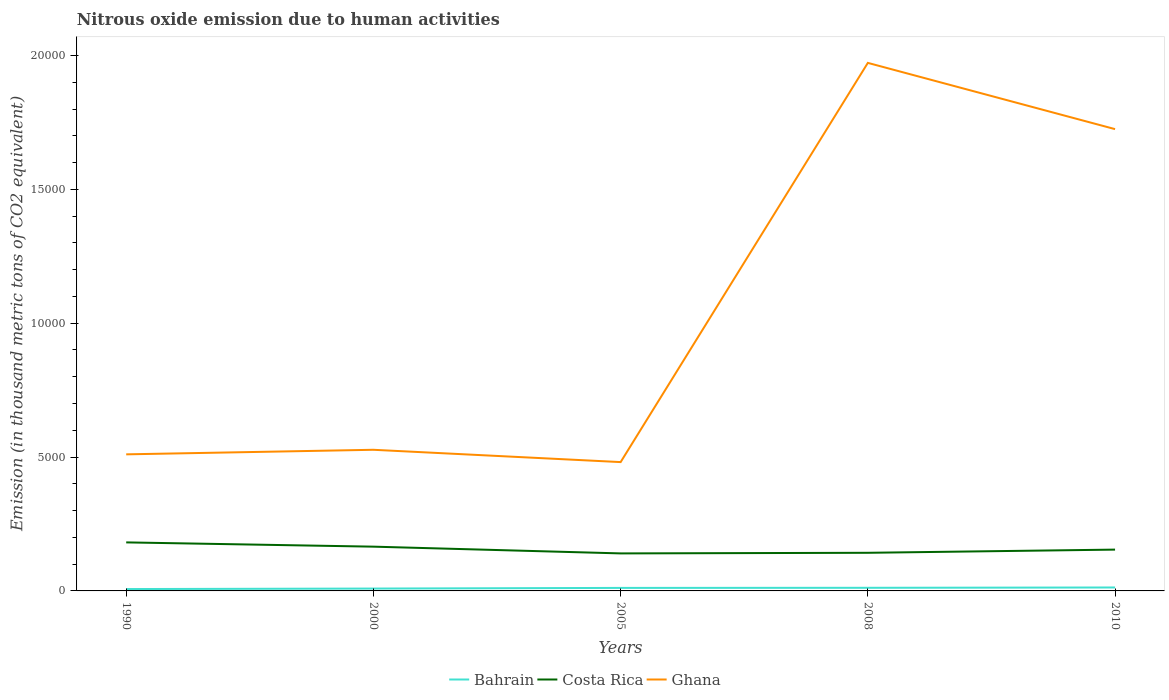How many different coloured lines are there?
Provide a succinct answer. 3. Across all years, what is the maximum amount of nitrous oxide emitted in Bahrain?
Your answer should be compact. 70.2. What is the total amount of nitrous oxide emitted in Costa Rica in the graph?
Provide a short and direct response. 411.5. What is the difference between the highest and the second highest amount of nitrous oxide emitted in Costa Rica?
Your response must be concise. 411.5. Is the amount of nitrous oxide emitted in Bahrain strictly greater than the amount of nitrous oxide emitted in Costa Rica over the years?
Your response must be concise. Yes. What is the difference between two consecutive major ticks on the Y-axis?
Your answer should be compact. 5000. Does the graph contain any zero values?
Provide a short and direct response. No. Does the graph contain grids?
Provide a succinct answer. No. How many legend labels are there?
Make the answer very short. 3. How are the legend labels stacked?
Your answer should be very brief. Horizontal. What is the title of the graph?
Your answer should be compact. Nitrous oxide emission due to human activities. Does "Bahrain" appear as one of the legend labels in the graph?
Your answer should be very brief. Yes. What is the label or title of the X-axis?
Your response must be concise. Years. What is the label or title of the Y-axis?
Keep it short and to the point. Emission (in thousand metric tons of CO2 equivalent). What is the Emission (in thousand metric tons of CO2 equivalent) of Bahrain in 1990?
Provide a succinct answer. 70.2. What is the Emission (in thousand metric tons of CO2 equivalent) of Costa Rica in 1990?
Keep it short and to the point. 1812.5. What is the Emission (in thousand metric tons of CO2 equivalent) of Ghana in 1990?
Keep it short and to the point. 5101.4. What is the Emission (in thousand metric tons of CO2 equivalent) of Bahrain in 2000?
Offer a terse response. 88.2. What is the Emission (in thousand metric tons of CO2 equivalent) of Costa Rica in 2000?
Your answer should be compact. 1653.2. What is the Emission (in thousand metric tons of CO2 equivalent) of Ghana in 2000?
Your answer should be compact. 5271.4. What is the Emission (in thousand metric tons of CO2 equivalent) in Bahrain in 2005?
Make the answer very short. 112.9. What is the Emission (in thousand metric tons of CO2 equivalent) in Costa Rica in 2005?
Offer a terse response. 1401. What is the Emission (in thousand metric tons of CO2 equivalent) in Ghana in 2005?
Provide a succinct answer. 4812. What is the Emission (in thousand metric tons of CO2 equivalent) in Bahrain in 2008?
Ensure brevity in your answer.  116.7. What is the Emission (in thousand metric tons of CO2 equivalent) in Costa Rica in 2008?
Make the answer very short. 1424.1. What is the Emission (in thousand metric tons of CO2 equivalent) in Ghana in 2008?
Provide a succinct answer. 1.97e+04. What is the Emission (in thousand metric tons of CO2 equivalent) in Bahrain in 2010?
Give a very brief answer. 128.6. What is the Emission (in thousand metric tons of CO2 equivalent) of Costa Rica in 2010?
Make the answer very short. 1543. What is the Emission (in thousand metric tons of CO2 equivalent) of Ghana in 2010?
Provide a succinct answer. 1.72e+04. Across all years, what is the maximum Emission (in thousand metric tons of CO2 equivalent) of Bahrain?
Your answer should be compact. 128.6. Across all years, what is the maximum Emission (in thousand metric tons of CO2 equivalent) in Costa Rica?
Your answer should be compact. 1812.5. Across all years, what is the maximum Emission (in thousand metric tons of CO2 equivalent) of Ghana?
Keep it short and to the point. 1.97e+04. Across all years, what is the minimum Emission (in thousand metric tons of CO2 equivalent) of Bahrain?
Make the answer very short. 70.2. Across all years, what is the minimum Emission (in thousand metric tons of CO2 equivalent) in Costa Rica?
Provide a succinct answer. 1401. Across all years, what is the minimum Emission (in thousand metric tons of CO2 equivalent) of Ghana?
Keep it short and to the point. 4812. What is the total Emission (in thousand metric tons of CO2 equivalent) of Bahrain in the graph?
Offer a terse response. 516.6. What is the total Emission (in thousand metric tons of CO2 equivalent) in Costa Rica in the graph?
Ensure brevity in your answer.  7833.8. What is the total Emission (in thousand metric tons of CO2 equivalent) in Ghana in the graph?
Your answer should be compact. 5.22e+04. What is the difference between the Emission (in thousand metric tons of CO2 equivalent) of Bahrain in 1990 and that in 2000?
Your response must be concise. -18. What is the difference between the Emission (in thousand metric tons of CO2 equivalent) of Costa Rica in 1990 and that in 2000?
Your answer should be compact. 159.3. What is the difference between the Emission (in thousand metric tons of CO2 equivalent) in Ghana in 1990 and that in 2000?
Your answer should be very brief. -170. What is the difference between the Emission (in thousand metric tons of CO2 equivalent) in Bahrain in 1990 and that in 2005?
Give a very brief answer. -42.7. What is the difference between the Emission (in thousand metric tons of CO2 equivalent) of Costa Rica in 1990 and that in 2005?
Offer a terse response. 411.5. What is the difference between the Emission (in thousand metric tons of CO2 equivalent) in Ghana in 1990 and that in 2005?
Ensure brevity in your answer.  289.4. What is the difference between the Emission (in thousand metric tons of CO2 equivalent) of Bahrain in 1990 and that in 2008?
Provide a short and direct response. -46.5. What is the difference between the Emission (in thousand metric tons of CO2 equivalent) in Costa Rica in 1990 and that in 2008?
Give a very brief answer. 388.4. What is the difference between the Emission (in thousand metric tons of CO2 equivalent) of Ghana in 1990 and that in 2008?
Your answer should be compact. -1.46e+04. What is the difference between the Emission (in thousand metric tons of CO2 equivalent) of Bahrain in 1990 and that in 2010?
Provide a short and direct response. -58.4. What is the difference between the Emission (in thousand metric tons of CO2 equivalent) of Costa Rica in 1990 and that in 2010?
Give a very brief answer. 269.5. What is the difference between the Emission (in thousand metric tons of CO2 equivalent) in Ghana in 1990 and that in 2010?
Make the answer very short. -1.21e+04. What is the difference between the Emission (in thousand metric tons of CO2 equivalent) in Bahrain in 2000 and that in 2005?
Your answer should be compact. -24.7. What is the difference between the Emission (in thousand metric tons of CO2 equivalent) in Costa Rica in 2000 and that in 2005?
Keep it short and to the point. 252.2. What is the difference between the Emission (in thousand metric tons of CO2 equivalent) of Ghana in 2000 and that in 2005?
Offer a terse response. 459.4. What is the difference between the Emission (in thousand metric tons of CO2 equivalent) of Bahrain in 2000 and that in 2008?
Make the answer very short. -28.5. What is the difference between the Emission (in thousand metric tons of CO2 equivalent) in Costa Rica in 2000 and that in 2008?
Offer a very short reply. 229.1. What is the difference between the Emission (in thousand metric tons of CO2 equivalent) in Ghana in 2000 and that in 2008?
Provide a short and direct response. -1.45e+04. What is the difference between the Emission (in thousand metric tons of CO2 equivalent) of Bahrain in 2000 and that in 2010?
Give a very brief answer. -40.4. What is the difference between the Emission (in thousand metric tons of CO2 equivalent) in Costa Rica in 2000 and that in 2010?
Your answer should be very brief. 110.2. What is the difference between the Emission (in thousand metric tons of CO2 equivalent) of Ghana in 2000 and that in 2010?
Provide a succinct answer. -1.20e+04. What is the difference between the Emission (in thousand metric tons of CO2 equivalent) of Bahrain in 2005 and that in 2008?
Provide a succinct answer. -3.8. What is the difference between the Emission (in thousand metric tons of CO2 equivalent) of Costa Rica in 2005 and that in 2008?
Offer a terse response. -23.1. What is the difference between the Emission (in thousand metric tons of CO2 equivalent) in Ghana in 2005 and that in 2008?
Provide a short and direct response. -1.49e+04. What is the difference between the Emission (in thousand metric tons of CO2 equivalent) of Bahrain in 2005 and that in 2010?
Your response must be concise. -15.7. What is the difference between the Emission (in thousand metric tons of CO2 equivalent) of Costa Rica in 2005 and that in 2010?
Provide a short and direct response. -142. What is the difference between the Emission (in thousand metric tons of CO2 equivalent) in Ghana in 2005 and that in 2010?
Your response must be concise. -1.24e+04. What is the difference between the Emission (in thousand metric tons of CO2 equivalent) in Costa Rica in 2008 and that in 2010?
Your answer should be compact. -118.9. What is the difference between the Emission (in thousand metric tons of CO2 equivalent) of Ghana in 2008 and that in 2010?
Provide a succinct answer. 2474. What is the difference between the Emission (in thousand metric tons of CO2 equivalent) of Bahrain in 1990 and the Emission (in thousand metric tons of CO2 equivalent) of Costa Rica in 2000?
Ensure brevity in your answer.  -1583. What is the difference between the Emission (in thousand metric tons of CO2 equivalent) of Bahrain in 1990 and the Emission (in thousand metric tons of CO2 equivalent) of Ghana in 2000?
Give a very brief answer. -5201.2. What is the difference between the Emission (in thousand metric tons of CO2 equivalent) in Costa Rica in 1990 and the Emission (in thousand metric tons of CO2 equivalent) in Ghana in 2000?
Give a very brief answer. -3458.9. What is the difference between the Emission (in thousand metric tons of CO2 equivalent) of Bahrain in 1990 and the Emission (in thousand metric tons of CO2 equivalent) of Costa Rica in 2005?
Your answer should be compact. -1330.8. What is the difference between the Emission (in thousand metric tons of CO2 equivalent) in Bahrain in 1990 and the Emission (in thousand metric tons of CO2 equivalent) in Ghana in 2005?
Ensure brevity in your answer.  -4741.8. What is the difference between the Emission (in thousand metric tons of CO2 equivalent) of Costa Rica in 1990 and the Emission (in thousand metric tons of CO2 equivalent) of Ghana in 2005?
Offer a very short reply. -2999.5. What is the difference between the Emission (in thousand metric tons of CO2 equivalent) in Bahrain in 1990 and the Emission (in thousand metric tons of CO2 equivalent) in Costa Rica in 2008?
Your response must be concise. -1353.9. What is the difference between the Emission (in thousand metric tons of CO2 equivalent) in Bahrain in 1990 and the Emission (in thousand metric tons of CO2 equivalent) in Ghana in 2008?
Provide a short and direct response. -1.97e+04. What is the difference between the Emission (in thousand metric tons of CO2 equivalent) of Costa Rica in 1990 and the Emission (in thousand metric tons of CO2 equivalent) of Ghana in 2008?
Your answer should be very brief. -1.79e+04. What is the difference between the Emission (in thousand metric tons of CO2 equivalent) of Bahrain in 1990 and the Emission (in thousand metric tons of CO2 equivalent) of Costa Rica in 2010?
Give a very brief answer. -1472.8. What is the difference between the Emission (in thousand metric tons of CO2 equivalent) in Bahrain in 1990 and the Emission (in thousand metric tons of CO2 equivalent) in Ghana in 2010?
Offer a terse response. -1.72e+04. What is the difference between the Emission (in thousand metric tons of CO2 equivalent) of Costa Rica in 1990 and the Emission (in thousand metric tons of CO2 equivalent) of Ghana in 2010?
Offer a very short reply. -1.54e+04. What is the difference between the Emission (in thousand metric tons of CO2 equivalent) in Bahrain in 2000 and the Emission (in thousand metric tons of CO2 equivalent) in Costa Rica in 2005?
Give a very brief answer. -1312.8. What is the difference between the Emission (in thousand metric tons of CO2 equivalent) of Bahrain in 2000 and the Emission (in thousand metric tons of CO2 equivalent) of Ghana in 2005?
Offer a very short reply. -4723.8. What is the difference between the Emission (in thousand metric tons of CO2 equivalent) of Costa Rica in 2000 and the Emission (in thousand metric tons of CO2 equivalent) of Ghana in 2005?
Provide a succinct answer. -3158.8. What is the difference between the Emission (in thousand metric tons of CO2 equivalent) of Bahrain in 2000 and the Emission (in thousand metric tons of CO2 equivalent) of Costa Rica in 2008?
Ensure brevity in your answer.  -1335.9. What is the difference between the Emission (in thousand metric tons of CO2 equivalent) in Bahrain in 2000 and the Emission (in thousand metric tons of CO2 equivalent) in Ghana in 2008?
Give a very brief answer. -1.96e+04. What is the difference between the Emission (in thousand metric tons of CO2 equivalent) in Costa Rica in 2000 and the Emission (in thousand metric tons of CO2 equivalent) in Ghana in 2008?
Offer a terse response. -1.81e+04. What is the difference between the Emission (in thousand metric tons of CO2 equivalent) in Bahrain in 2000 and the Emission (in thousand metric tons of CO2 equivalent) in Costa Rica in 2010?
Ensure brevity in your answer.  -1454.8. What is the difference between the Emission (in thousand metric tons of CO2 equivalent) of Bahrain in 2000 and the Emission (in thousand metric tons of CO2 equivalent) of Ghana in 2010?
Your response must be concise. -1.72e+04. What is the difference between the Emission (in thousand metric tons of CO2 equivalent) in Costa Rica in 2000 and the Emission (in thousand metric tons of CO2 equivalent) in Ghana in 2010?
Make the answer very short. -1.56e+04. What is the difference between the Emission (in thousand metric tons of CO2 equivalent) in Bahrain in 2005 and the Emission (in thousand metric tons of CO2 equivalent) in Costa Rica in 2008?
Your response must be concise. -1311.2. What is the difference between the Emission (in thousand metric tons of CO2 equivalent) of Bahrain in 2005 and the Emission (in thousand metric tons of CO2 equivalent) of Ghana in 2008?
Provide a succinct answer. -1.96e+04. What is the difference between the Emission (in thousand metric tons of CO2 equivalent) in Costa Rica in 2005 and the Emission (in thousand metric tons of CO2 equivalent) in Ghana in 2008?
Provide a succinct answer. -1.83e+04. What is the difference between the Emission (in thousand metric tons of CO2 equivalent) of Bahrain in 2005 and the Emission (in thousand metric tons of CO2 equivalent) of Costa Rica in 2010?
Provide a short and direct response. -1430.1. What is the difference between the Emission (in thousand metric tons of CO2 equivalent) of Bahrain in 2005 and the Emission (in thousand metric tons of CO2 equivalent) of Ghana in 2010?
Offer a very short reply. -1.71e+04. What is the difference between the Emission (in thousand metric tons of CO2 equivalent) in Costa Rica in 2005 and the Emission (in thousand metric tons of CO2 equivalent) in Ghana in 2010?
Your answer should be compact. -1.58e+04. What is the difference between the Emission (in thousand metric tons of CO2 equivalent) of Bahrain in 2008 and the Emission (in thousand metric tons of CO2 equivalent) of Costa Rica in 2010?
Give a very brief answer. -1426.3. What is the difference between the Emission (in thousand metric tons of CO2 equivalent) of Bahrain in 2008 and the Emission (in thousand metric tons of CO2 equivalent) of Ghana in 2010?
Your answer should be very brief. -1.71e+04. What is the difference between the Emission (in thousand metric tons of CO2 equivalent) in Costa Rica in 2008 and the Emission (in thousand metric tons of CO2 equivalent) in Ghana in 2010?
Your answer should be compact. -1.58e+04. What is the average Emission (in thousand metric tons of CO2 equivalent) in Bahrain per year?
Your answer should be very brief. 103.32. What is the average Emission (in thousand metric tons of CO2 equivalent) of Costa Rica per year?
Make the answer very short. 1566.76. What is the average Emission (in thousand metric tons of CO2 equivalent) of Ghana per year?
Offer a very short reply. 1.04e+04. In the year 1990, what is the difference between the Emission (in thousand metric tons of CO2 equivalent) of Bahrain and Emission (in thousand metric tons of CO2 equivalent) of Costa Rica?
Your answer should be compact. -1742.3. In the year 1990, what is the difference between the Emission (in thousand metric tons of CO2 equivalent) in Bahrain and Emission (in thousand metric tons of CO2 equivalent) in Ghana?
Provide a short and direct response. -5031.2. In the year 1990, what is the difference between the Emission (in thousand metric tons of CO2 equivalent) of Costa Rica and Emission (in thousand metric tons of CO2 equivalent) of Ghana?
Offer a terse response. -3288.9. In the year 2000, what is the difference between the Emission (in thousand metric tons of CO2 equivalent) in Bahrain and Emission (in thousand metric tons of CO2 equivalent) in Costa Rica?
Offer a terse response. -1565. In the year 2000, what is the difference between the Emission (in thousand metric tons of CO2 equivalent) in Bahrain and Emission (in thousand metric tons of CO2 equivalent) in Ghana?
Your answer should be very brief. -5183.2. In the year 2000, what is the difference between the Emission (in thousand metric tons of CO2 equivalent) of Costa Rica and Emission (in thousand metric tons of CO2 equivalent) of Ghana?
Your response must be concise. -3618.2. In the year 2005, what is the difference between the Emission (in thousand metric tons of CO2 equivalent) in Bahrain and Emission (in thousand metric tons of CO2 equivalent) in Costa Rica?
Provide a short and direct response. -1288.1. In the year 2005, what is the difference between the Emission (in thousand metric tons of CO2 equivalent) in Bahrain and Emission (in thousand metric tons of CO2 equivalent) in Ghana?
Your answer should be compact. -4699.1. In the year 2005, what is the difference between the Emission (in thousand metric tons of CO2 equivalent) in Costa Rica and Emission (in thousand metric tons of CO2 equivalent) in Ghana?
Your answer should be very brief. -3411. In the year 2008, what is the difference between the Emission (in thousand metric tons of CO2 equivalent) of Bahrain and Emission (in thousand metric tons of CO2 equivalent) of Costa Rica?
Offer a terse response. -1307.4. In the year 2008, what is the difference between the Emission (in thousand metric tons of CO2 equivalent) of Bahrain and Emission (in thousand metric tons of CO2 equivalent) of Ghana?
Provide a succinct answer. -1.96e+04. In the year 2008, what is the difference between the Emission (in thousand metric tons of CO2 equivalent) in Costa Rica and Emission (in thousand metric tons of CO2 equivalent) in Ghana?
Your answer should be very brief. -1.83e+04. In the year 2010, what is the difference between the Emission (in thousand metric tons of CO2 equivalent) in Bahrain and Emission (in thousand metric tons of CO2 equivalent) in Costa Rica?
Offer a very short reply. -1414.4. In the year 2010, what is the difference between the Emission (in thousand metric tons of CO2 equivalent) of Bahrain and Emission (in thousand metric tons of CO2 equivalent) of Ghana?
Offer a terse response. -1.71e+04. In the year 2010, what is the difference between the Emission (in thousand metric tons of CO2 equivalent) of Costa Rica and Emission (in thousand metric tons of CO2 equivalent) of Ghana?
Provide a short and direct response. -1.57e+04. What is the ratio of the Emission (in thousand metric tons of CO2 equivalent) in Bahrain in 1990 to that in 2000?
Keep it short and to the point. 0.8. What is the ratio of the Emission (in thousand metric tons of CO2 equivalent) of Costa Rica in 1990 to that in 2000?
Ensure brevity in your answer.  1.1. What is the ratio of the Emission (in thousand metric tons of CO2 equivalent) in Ghana in 1990 to that in 2000?
Give a very brief answer. 0.97. What is the ratio of the Emission (in thousand metric tons of CO2 equivalent) in Bahrain in 1990 to that in 2005?
Keep it short and to the point. 0.62. What is the ratio of the Emission (in thousand metric tons of CO2 equivalent) in Costa Rica in 1990 to that in 2005?
Give a very brief answer. 1.29. What is the ratio of the Emission (in thousand metric tons of CO2 equivalent) of Ghana in 1990 to that in 2005?
Provide a short and direct response. 1.06. What is the ratio of the Emission (in thousand metric tons of CO2 equivalent) in Bahrain in 1990 to that in 2008?
Provide a short and direct response. 0.6. What is the ratio of the Emission (in thousand metric tons of CO2 equivalent) in Costa Rica in 1990 to that in 2008?
Provide a succinct answer. 1.27. What is the ratio of the Emission (in thousand metric tons of CO2 equivalent) in Ghana in 1990 to that in 2008?
Your answer should be compact. 0.26. What is the ratio of the Emission (in thousand metric tons of CO2 equivalent) in Bahrain in 1990 to that in 2010?
Your answer should be compact. 0.55. What is the ratio of the Emission (in thousand metric tons of CO2 equivalent) of Costa Rica in 1990 to that in 2010?
Your answer should be very brief. 1.17. What is the ratio of the Emission (in thousand metric tons of CO2 equivalent) in Ghana in 1990 to that in 2010?
Your answer should be compact. 0.3. What is the ratio of the Emission (in thousand metric tons of CO2 equivalent) in Bahrain in 2000 to that in 2005?
Provide a succinct answer. 0.78. What is the ratio of the Emission (in thousand metric tons of CO2 equivalent) in Costa Rica in 2000 to that in 2005?
Ensure brevity in your answer.  1.18. What is the ratio of the Emission (in thousand metric tons of CO2 equivalent) of Ghana in 2000 to that in 2005?
Offer a terse response. 1.1. What is the ratio of the Emission (in thousand metric tons of CO2 equivalent) in Bahrain in 2000 to that in 2008?
Provide a succinct answer. 0.76. What is the ratio of the Emission (in thousand metric tons of CO2 equivalent) of Costa Rica in 2000 to that in 2008?
Ensure brevity in your answer.  1.16. What is the ratio of the Emission (in thousand metric tons of CO2 equivalent) of Ghana in 2000 to that in 2008?
Ensure brevity in your answer.  0.27. What is the ratio of the Emission (in thousand metric tons of CO2 equivalent) in Bahrain in 2000 to that in 2010?
Ensure brevity in your answer.  0.69. What is the ratio of the Emission (in thousand metric tons of CO2 equivalent) in Costa Rica in 2000 to that in 2010?
Offer a terse response. 1.07. What is the ratio of the Emission (in thousand metric tons of CO2 equivalent) of Ghana in 2000 to that in 2010?
Offer a very short reply. 0.31. What is the ratio of the Emission (in thousand metric tons of CO2 equivalent) of Bahrain in 2005 to that in 2008?
Keep it short and to the point. 0.97. What is the ratio of the Emission (in thousand metric tons of CO2 equivalent) in Costa Rica in 2005 to that in 2008?
Keep it short and to the point. 0.98. What is the ratio of the Emission (in thousand metric tons of CO2 equivalent) in Ghana in 2005 to that in 2008?
Provide a short and direct response. 0.24. What is the ratio of the Emission (in thousand metric tons of CO2 equivalent) in Bahrain in 2005 to that in 2010?
Your answer should be very brief. 0.88. What is the ratio of the Emission (in thousand metric tons of CO2 equivalent) in Costa Rica in 2005 to that in 2010?
Keep it short and to the point. 0.91. What is the ratio of the Emission (in thousand metric tons of CO2 equivalent) of Ghana in 2005 to that in 2010?
Your answer should be compact. 0.28. What is the ratio of the Emission (in thousand metric tons of CO2 equivalent) of Bahrain in 2008 to that in 2010?
Your answer should be very brief. 0.91. What is the ratio of the Emission (in thousand metric tons of CO2 equivalent) of Costa Rica in 2008 to that in 2010?
Your response must be concise. 0.92. What is the ratio of the Emission (in thousand metric tons of CO2 equivalent) in Ghana in 2008 to that in 2010?
Make the answer very short. 1.14. What is the difference between the highest and the second highest Emission (in thousand metric tons of CO2 equivalent) in Bahrain?
Offer a terse response. 11.9. What is the difference between the highest and the second highest Emission (in thousand metric tons of CO2 equivalent) in Costa Rica?
Your answer should be very brief. 159.3. What is the difference between the highest and the second highest Emission (in thousand metric tons of CO2 equivalent) in Ghana?
Your response must be concise. 2474. What is the difference between the highest and the lowest Emission (in thousand metric tons of CO2 equivalent) in Bahrain?
Ensure brevity in your answer.  58.4. What is the difference between the highest and the lowest Emission (in thousand metric tons of CO2 equivalent) of Costa Rica?
Offer a very short reply. 411.5. What is the difference between the highest and the lowest Emission (in thousand metric tons of CO2 equivalent) in Ghana?
Your answer should be very brief. 1.49e+04. 